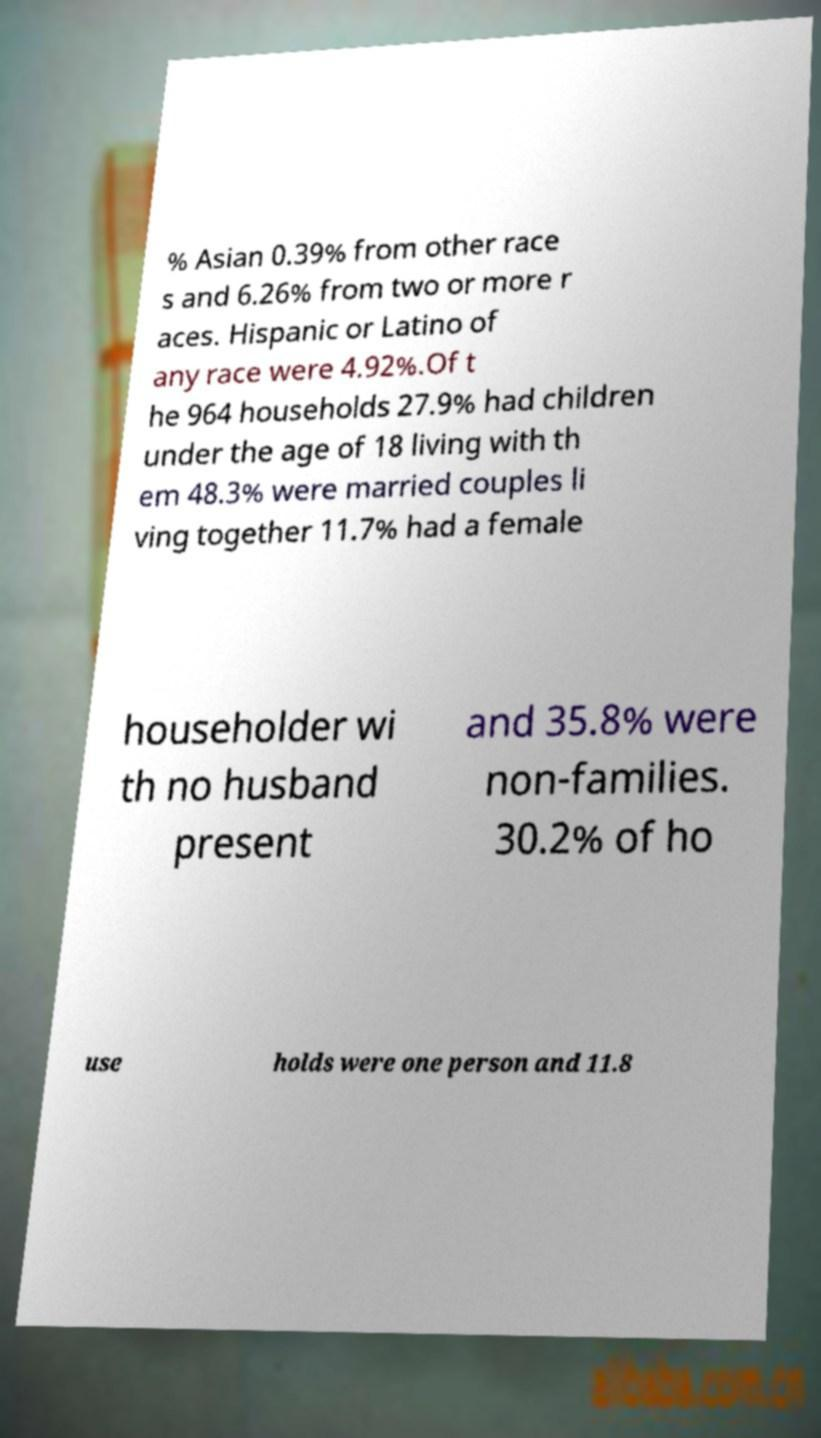Can you accurately transcribe the text from the provided image for me? % Asian 0.39% from other race s and 6.26% from two or more r aces. Hispanic or Latino of any race were 4.92%.Of t he 964 households 27.9% had children under the age of 18 living with th em 48.3% were married couples li ving together 11.7% had a female householder wi th no husband present and 35.8% were non-families. 30.2% of ho use holds were one person and 11.8 